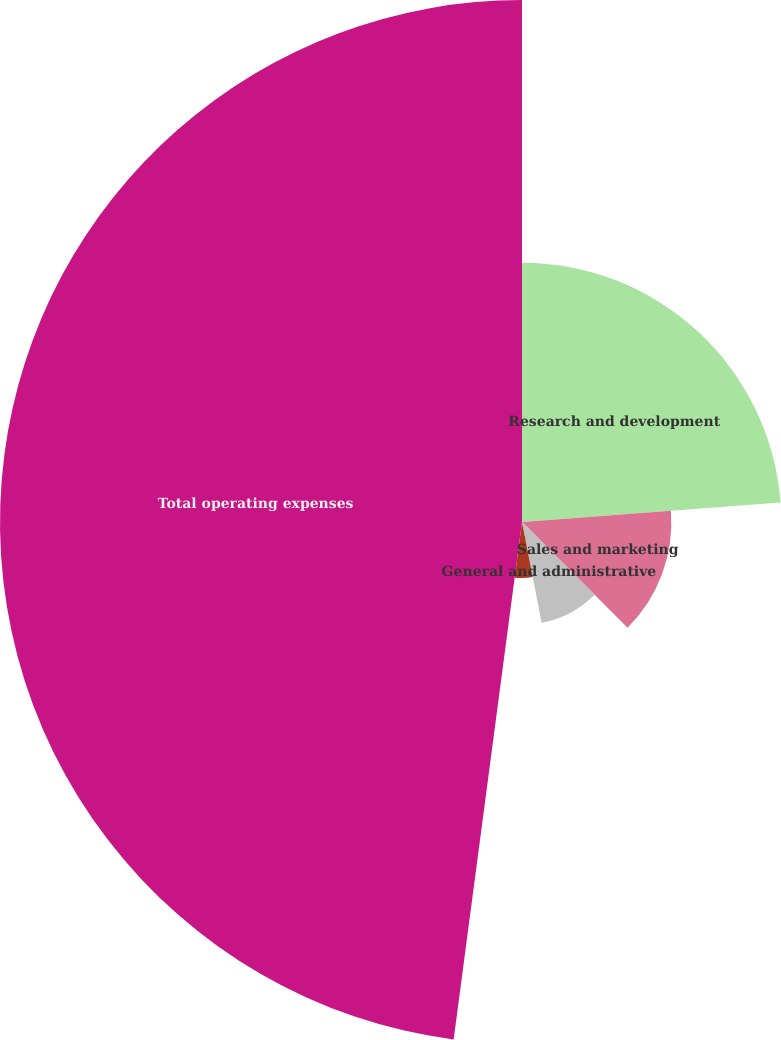Convert chart. <chart><loc_0><loc_0><loc_500><loc_500><pie_chart><fcel>Research and development<fcel>Sales and marketing<fcel>General and administrative<fcel>Restructuring and other<fcel>Total operating expenses<nl><fcel>23.8%<fcel>13.71%<fcel>9.43%<fcel>5.15%<fcel>47.91%<nl></chart> 